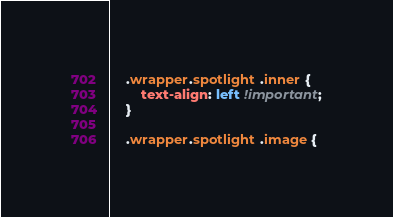<code> <loc_0><loc_0><loc_500><loc_500><_CSS_>	.wrapper.spotlight .inner {
		text-align: left !important;
	}

	.wrapper.spotlight .image {</code> 